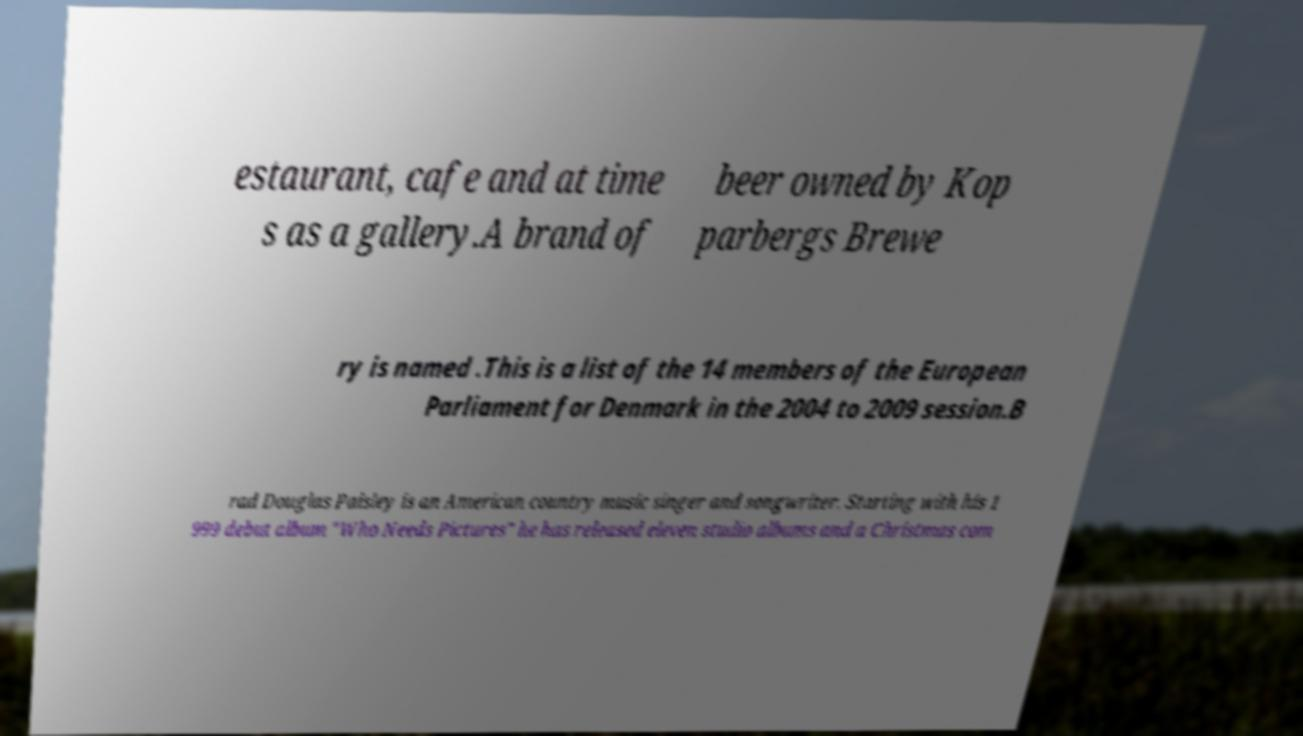Please read and relay the text visible in this image. What does it say? estaurant, cafe and at time s as a gallery.A brand of beer owned by Kop parbergs Brewe ry is named .This is a list of the 14 members of the European Parliament for Denmark in the 2004 to 2009 session.B rad Douglas Paisley is an American country music singer and songwriter. Starting with his 1 999 debut album "Who Needs Pictures" he has released eleven studio albums and a Christmas com 